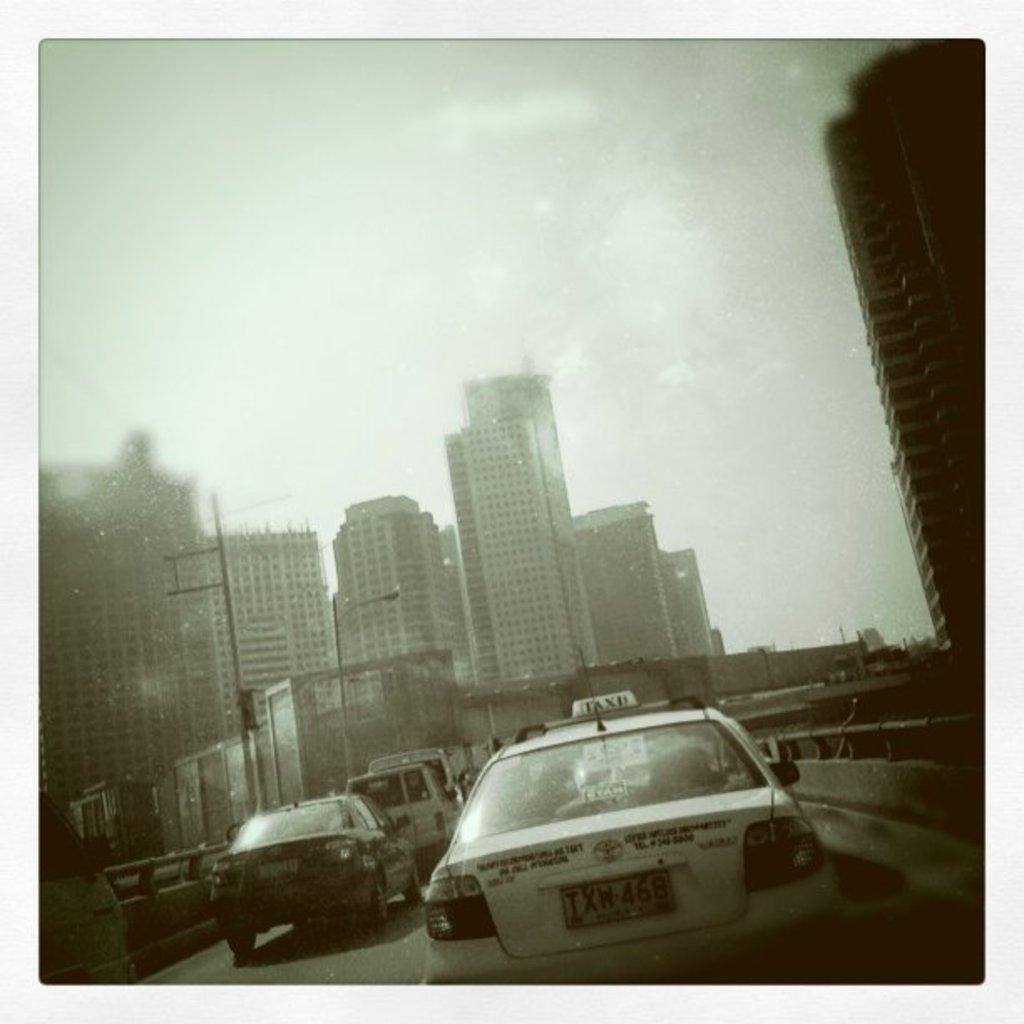What can be seen on the road in the image? There are vehicles on the road in the image. What type of structures are visible in the image? There are buildings in the image. What else can be seen in the image besides vehicles and buildings? There are poles and some objects in the image. What is visible in the background of the image? The sky is visible in the background of the image. Is there a game of chess being played in the image? There is no game of chess present in the image. What shape is the circle that is visible in the image? There is no circle visible in the image. 